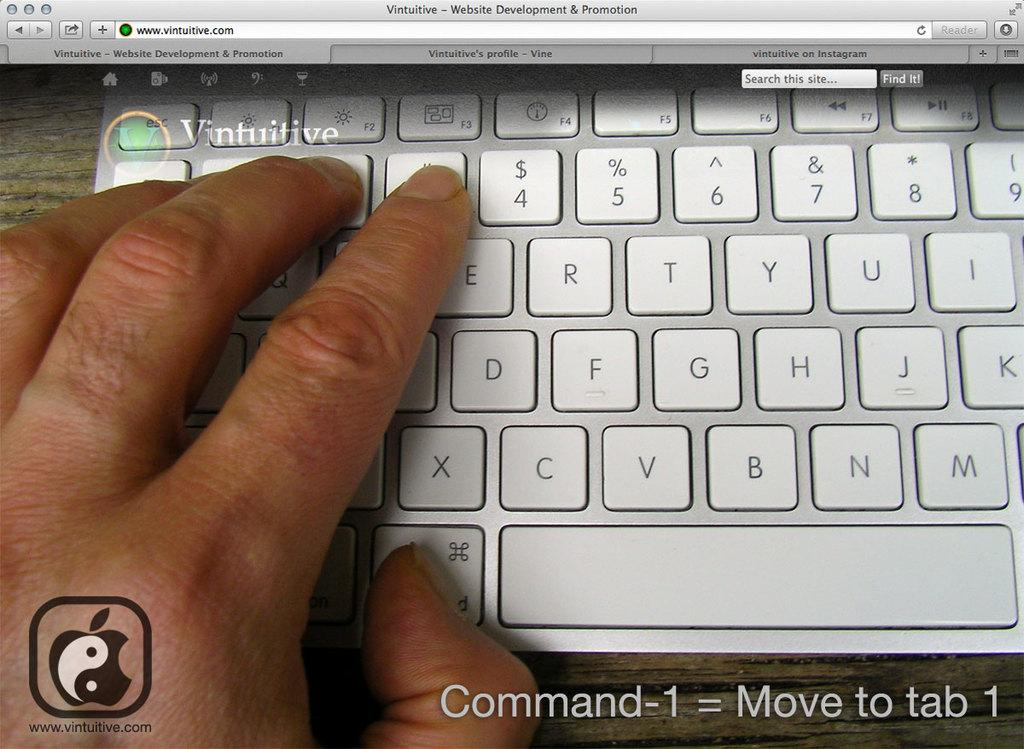<image>
Present a compact description of the photo's key features. Person pressing the keys on a keyboard typing in Vintuitive. 